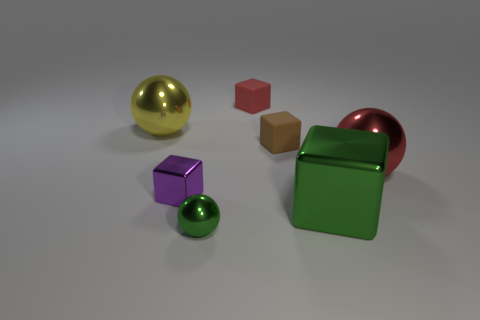Add 1 purple things. How many objects exist? 8 Subtract all cubes. How many objects are left? 3 Add 5 small red objects. How many small red objects are left? 6 Add 2 large red spheres. How many large red spheres exist? 3 Subtract 1 purple cubes. How many objects are left? 6 Subtract all red matte blocks. Subtract all green metallic things. How many objects are left? 4 